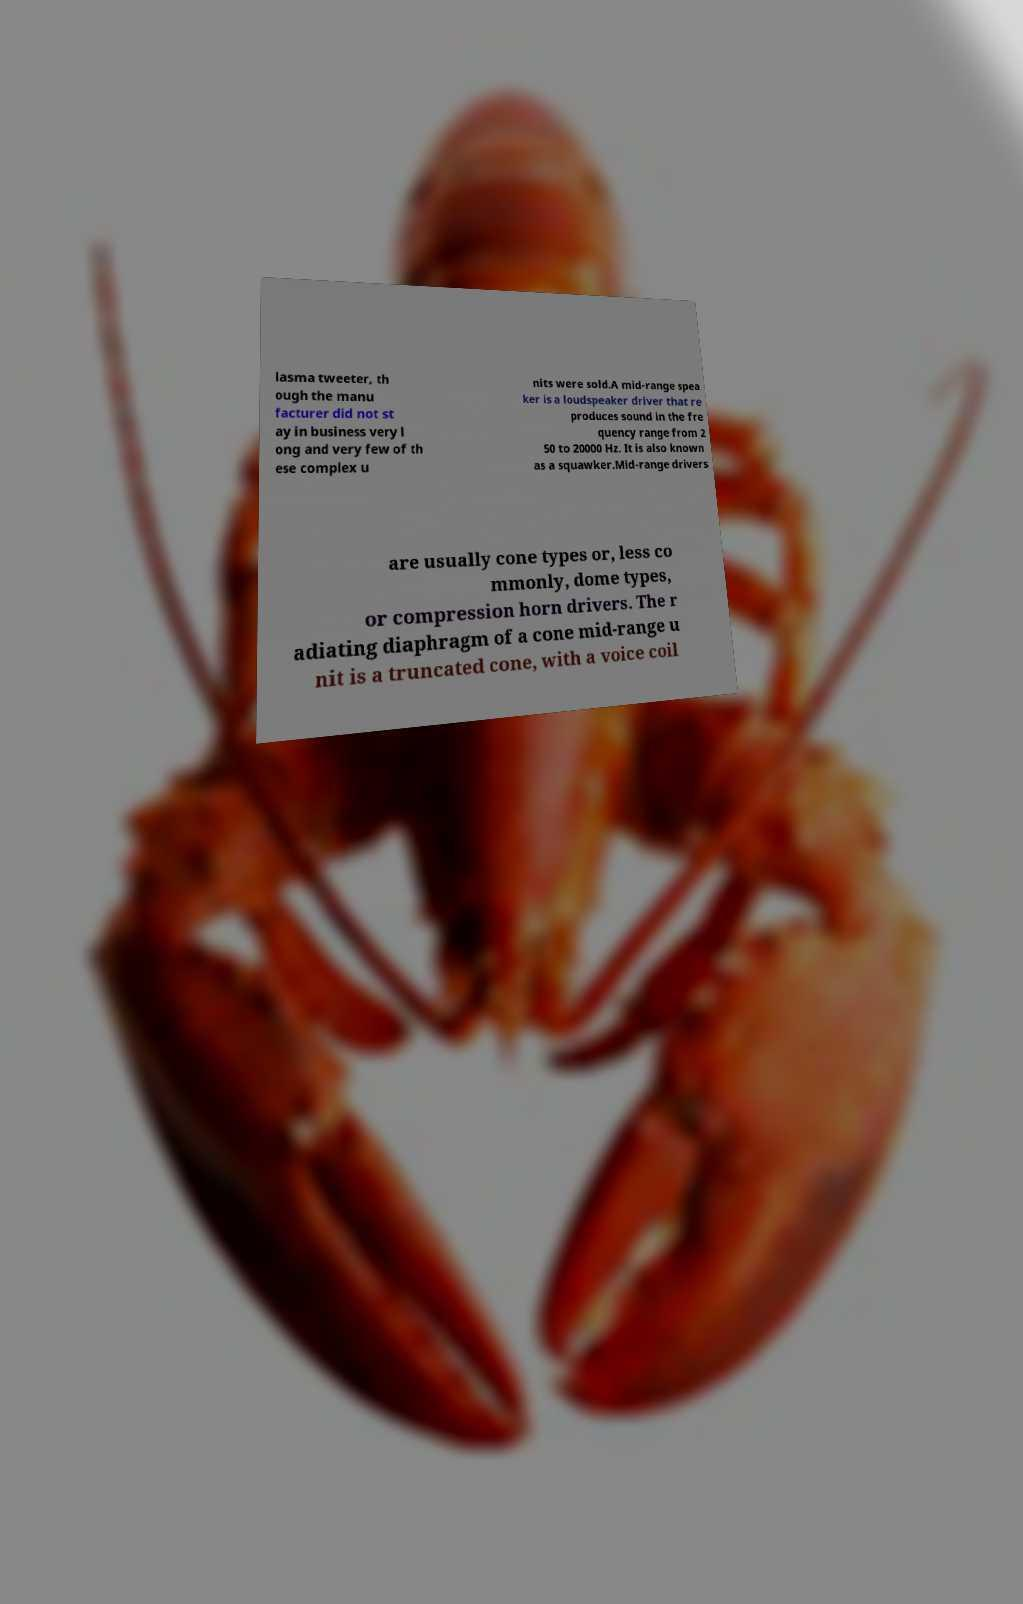Can you read and provide the text displayed in the image?This photo seems to have some interesting text. Can you extract and type it out for me? lasma tweeter, th ough the manu facturer did not st ay in business very l ong and very few of th ese complex u nits were sold.A mid-range spea ker is a loudspeaker driver that re produces sound in the fre quency range from 2 50 to 20000 Hz. It is also known as a squawker.Mid-range drivers are usually cone types or, less co mmonly, dome types, or compression horn drivers. The r adiating diaphragm of a cone mid-range u nit is a truncated cone, with a voice coil 